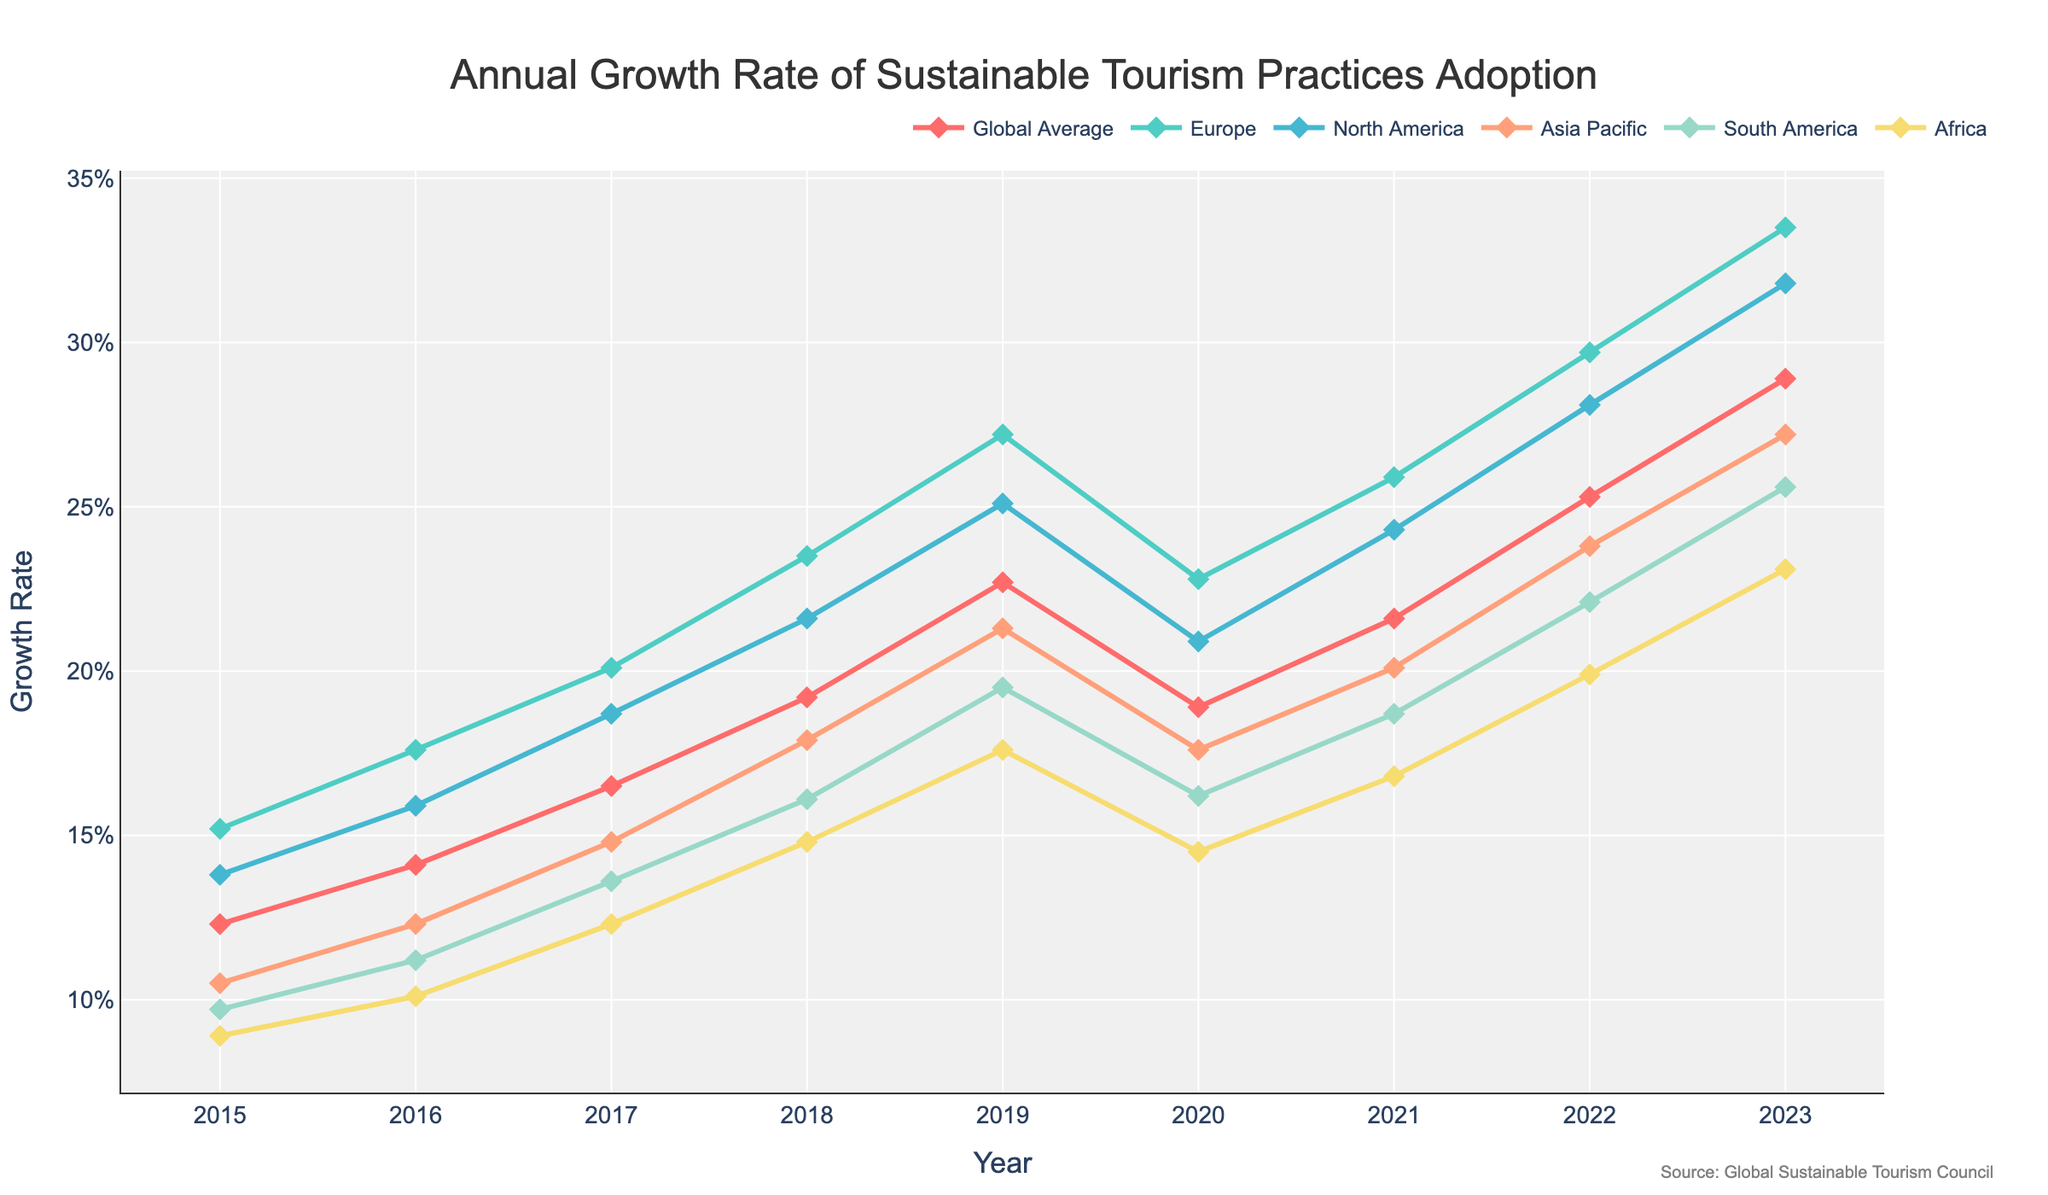what was the highest growth rate in Europe, and in which year did it occur? The highest growth rate in Europe can be found by looking for the peak value on the Europe line. The highest value is 33.5% in 2023.
Answer: 2023, 33.5% How did the global average growth rate change from 2020 to 2021? The global average growth rate in 2020 was 18.9% and it increased to 21.6% in 2021. The change is 21.6% - 18.9% = 2.7%.
Answer: Increased by 2.7% Which region showed the smallest growth rate in 2015? To find this, look at the growth rates for all regions in 2015. Africa had the smallest growth rate of 8.9%.
Answer: Africa Compare the growth rates of North America and Asia Pacific in 2017. Which was higher, and by how much? In 2017, North America had a growth rate of 18.7%, and Asia Pacific had a growth rate of 14.8%. The difference is 18.7% - 14.8% = 3.9%, with North America being higher.
Answer: North America, 3.9% What is the average growth rate of South America from 2015 to 2023? Sum the values for South America and divide by the number of years: (9.7% + 11.2% + 13.6% + 16.1% + 19.5% + 16.2% + 18.7% + 22.1% + 25.6%) / 9 = 16.3%.
Answer: 16.3% Was there any year when the global average growth rate decreased compared to the previous year? If yes, which year? The global average growth rate decreased from 22.7% in 2019 to 18.9% in 2020.
Answer: 2020 In 2023, which two regions had the closest growth rates, and what was the difference between them? In 2023, the growth rates were: Europe (33.5%), North America (31.8%), Asia Pacific (27.2%), South America (25.6%), and Africa (23.1%). South America (25.6%) and Africa (23.1%) are the closest with a difference of 25.6% - 23.1% = 2.5%.
Answer: South America and Africa, 2.5% Between 2019 and 2020, which region experienced the most significant drop in growth rate? The drop can be calculated for each region: Europe (27.2% to 22.8% = -4.4%), North America (25.1% to 20.9% = -4.2%), Asia Pacific (21.3% to 17.6% = -3.7%), South America (19.5% to 16.2% = -3.3%), Africa (17.6% to 14.5% = -3.1%). Europe had the most significant drop with 4.4%.
Answer: Europe What was the trend in adoption of sustainable tourism practices in North America from 2015 to 2023? Observing North America's growth rates, we see an overall increasing trend from 13.8% in 2015 to 31.8% in 2023, with a small drop in 2020.
Answer: Increasing trend with a dip in 2020 What is the difference in growth rates between Europe and Africa in 2022? In 2022, Europe had a growth rate of 29.7%, and Africa had a growth rate of 19.9%. The difference is 29.7% - 19.9% = 9.8%.
Answer: 9.8% 